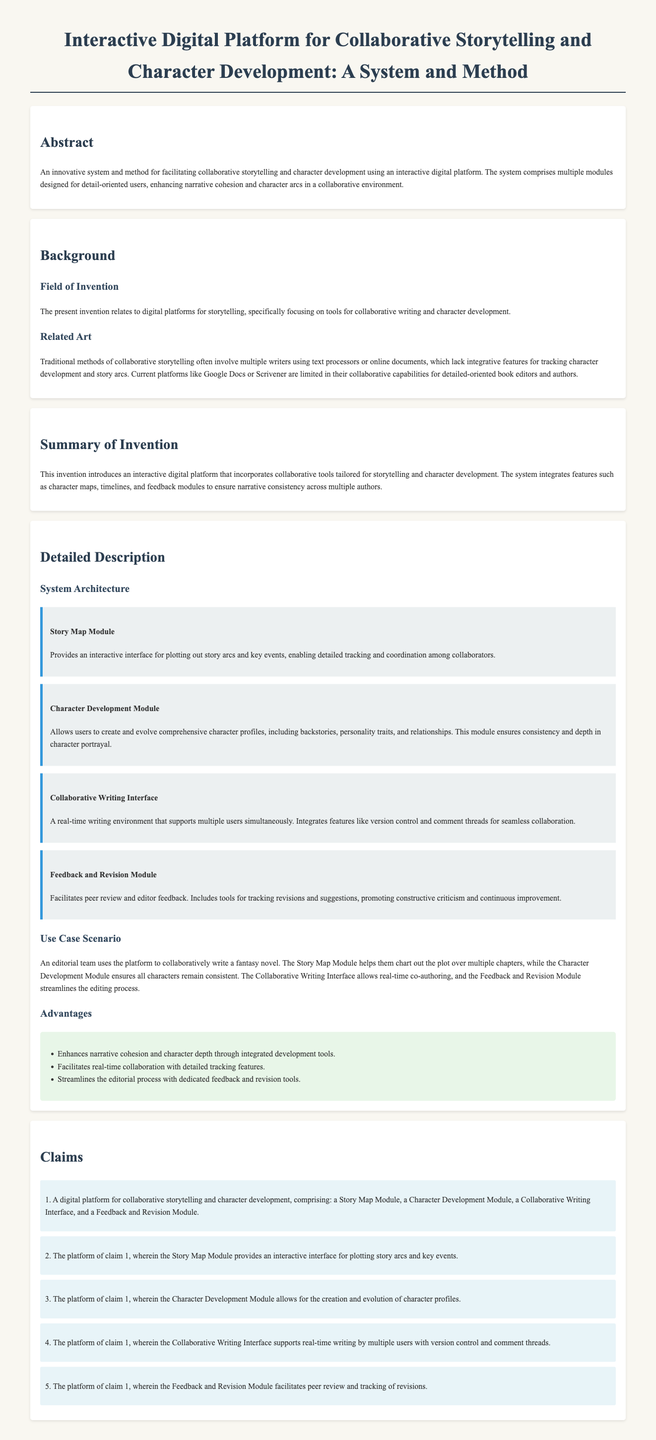What is the title of the document? The title is specified in the head section of the HTML document, summarizing the content focus on an interactive platform for storytelling.
Answer: Interactive Digital Platform for Collaborative Storytelling and Character Development: A System and Method What does the Character Development Module allow users to do? The detailed description outlines the capabilities of the module, emphasizing its focus on character portrayal.
Answer: Create and evolve comprehensive character profiles Which module provides an interactive interface for plotting story arcs? This is detailed in the system architecture section, highlighting its function within the overall platform.
Answer: Story Map Module How many claims are presented in the document? The claims section enumerates the features and functionalities of the platform, which are defined in a numbered format.
Answer: 5 What is one of the advantages of the platform? The advantages are listed in a bulleted format, showcasing benefits derived from using the platform.
Answer: Enhances narrative cohesion and character depth through integrated development tools What is the use case scenario mentioned in the detailed description? The use case illustrates a practical application of the platform, demonstrating its functionalities through a specific example.
Answer: An editorial team uses the platform to collaboratively write a fantasy novel What does the Feedback and Revision Module facilitate? This is explained in the detailed description, focusing on its role in the editorial process.
Answer: Peer review and tracking of revisions Which field does the invention relate to? The background section specifies the focus area of the invention in a concise statement.
Answer: Digital platforms for storytelling 